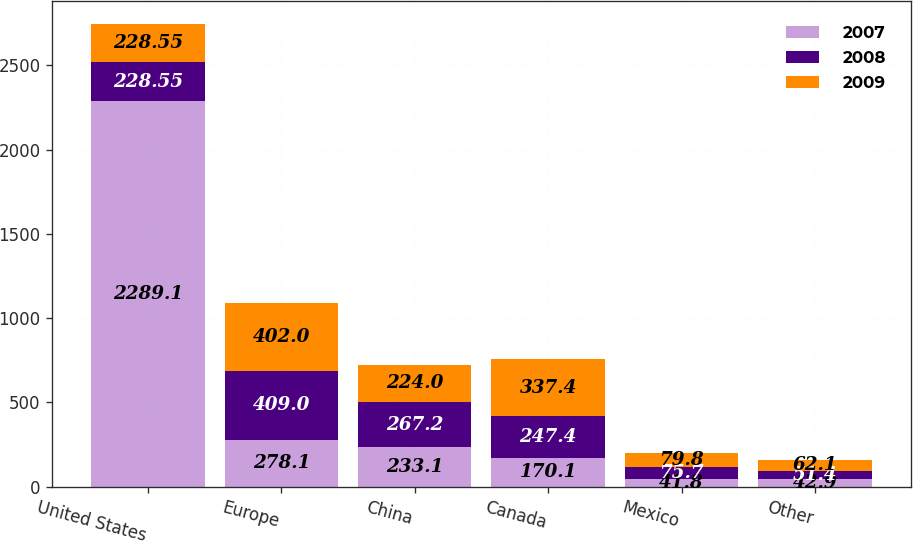<chart> <loc_0><loc_0><loc_500><loc_500><stacked_bar_chart><ecel><fcel>United States<fcel>Europe<fcel>China<fcel>Canada<fcel>Mexico<fcel>Other<nl><fcel>2007<fcel>2289.1<fcel>278.1<fcel>233.1<fcel>170.1<fcel>41.8<fcel>42.9<nl><fcel>2008<fcel>228.55<fcel>409<fcel>267.2<fcel>247.4<fcel>75.7<fcel>51.4<nl><fcel>2009<fcel>228.55<fcel>402<fcel>224<fcel>337.4<fcel>79.8<fcel>62.1<nl></chart> 